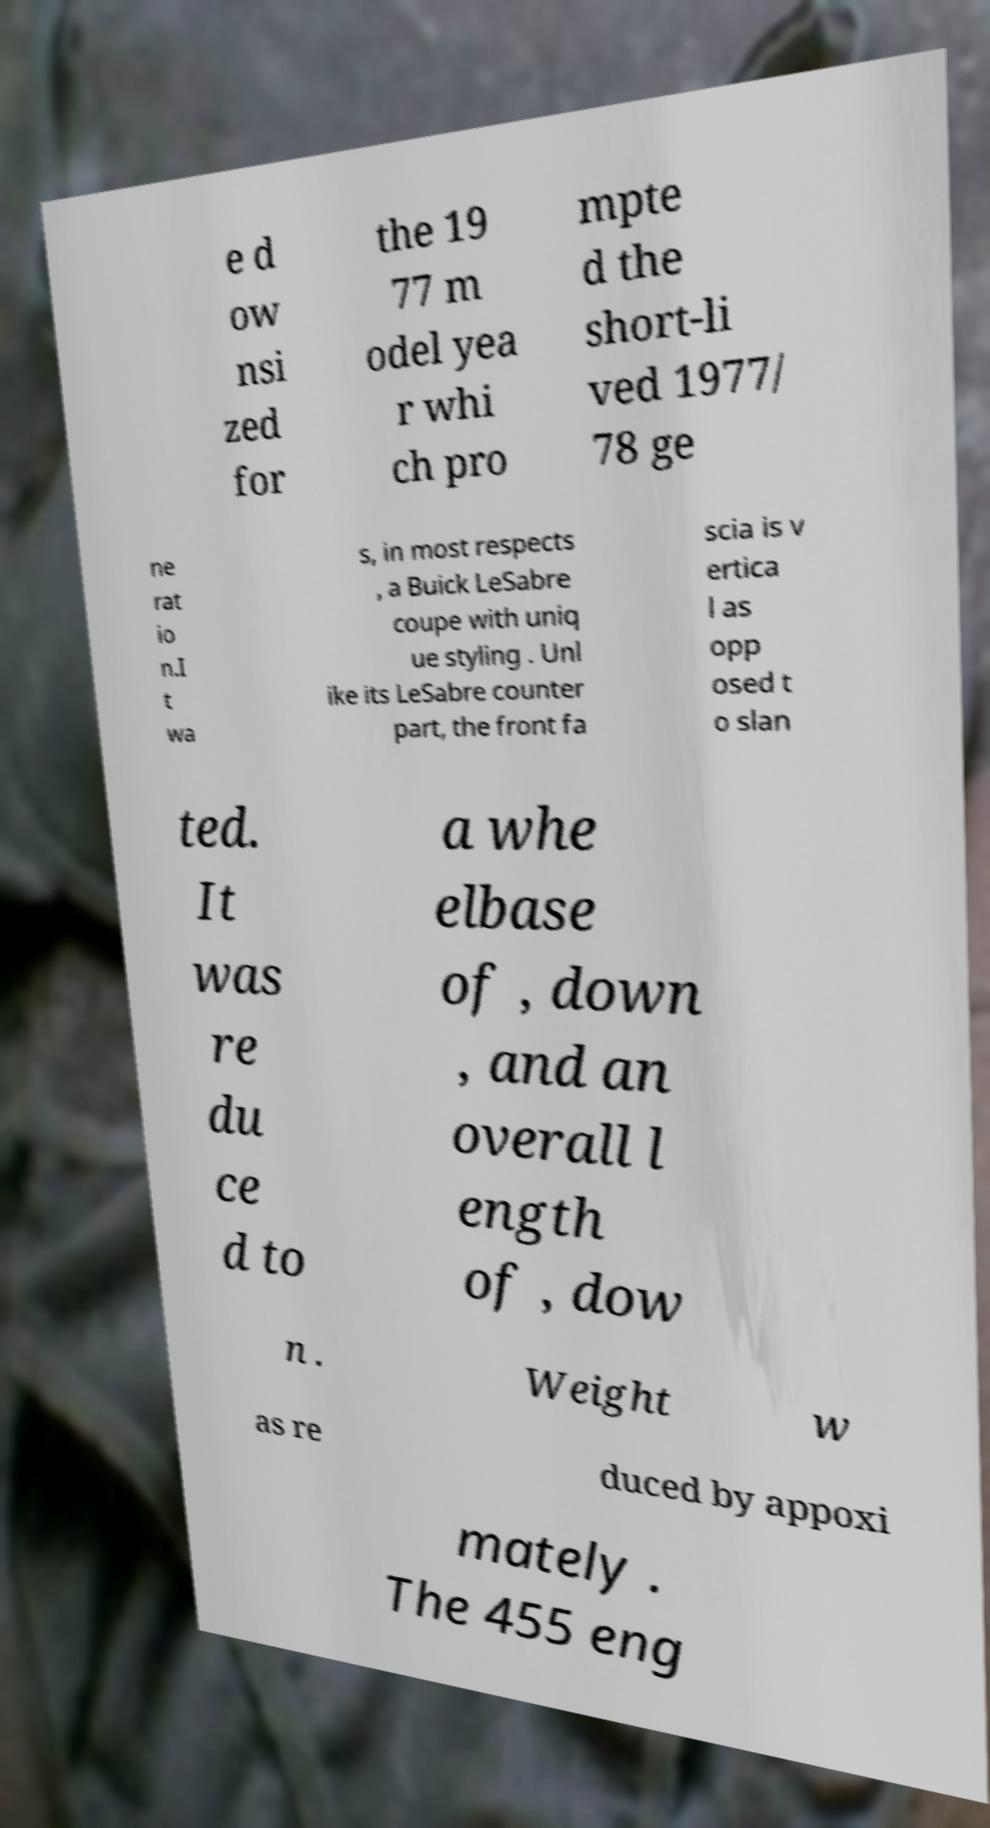There's text embedded in this image that I need extracted. Can you transcribe it verbatim? e d ow nsi zed for the 19 77 m odel yea r whi ch pro mpte d the short-li ved 1977/ 78 ge ne rat io n.I t wa s, in most respects , a Buick LeSabre coupe with uniq ue styling . Unl ike its LeSabre counter part, the front fa scia is v ertica l as opp osed t o slan ted. It was re du ce d to a whe elbase of , down , and an overall l ength of , dow n . Weight w as re duced by appoxi mately . The 455 eng 